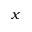Convert formula to latex. <formula><loc_0><loc_0><loc_500><loc_500>x</formula> 